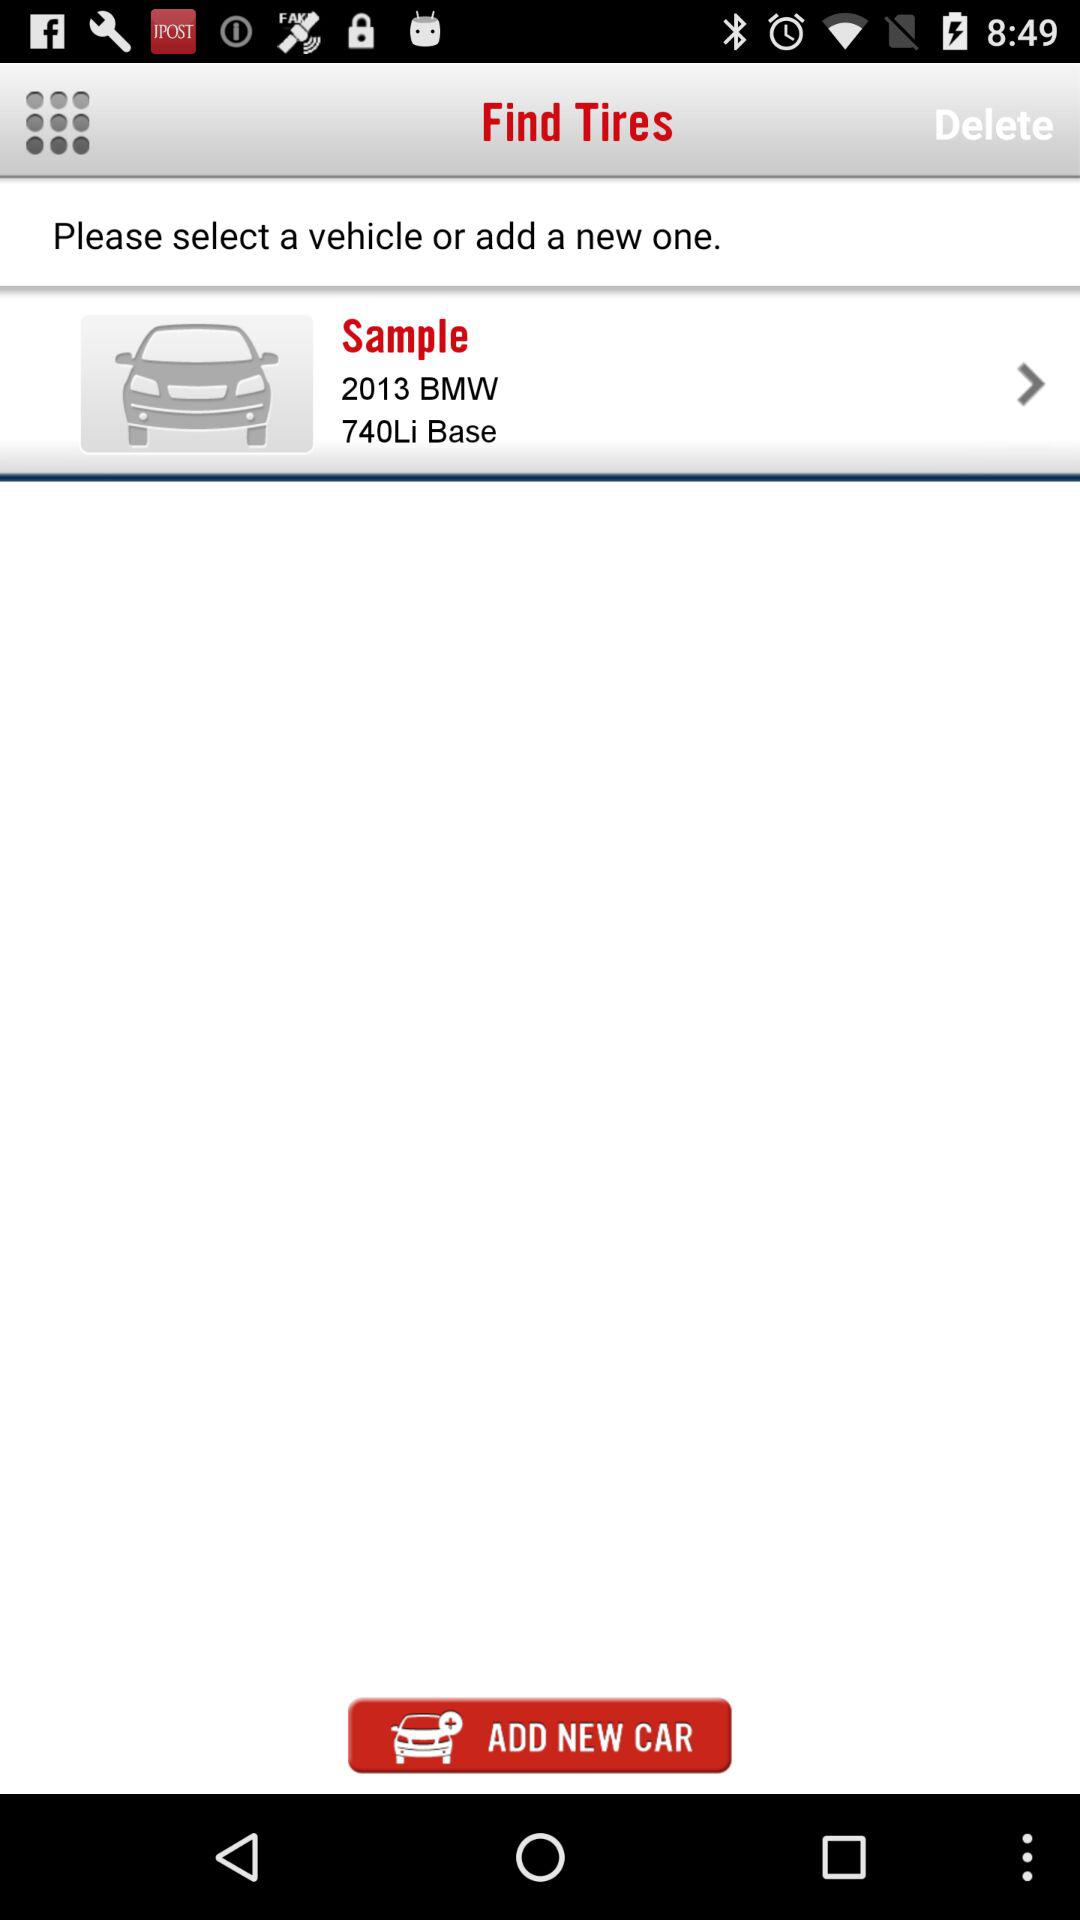Which model of car is selected for the sample? The selected model is the 740 Li base. 